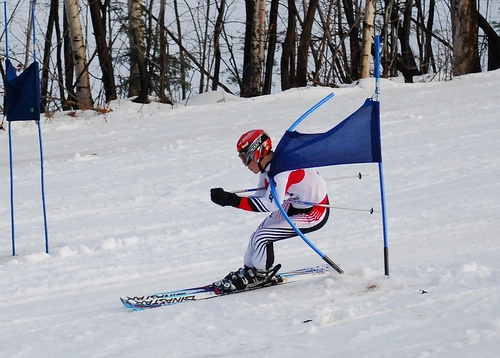Describe the objects in this image and their specific colors. I can see people in darkgray, black, and lavender tones and skis in darkgray, lightgray, and gray tones in this image. 